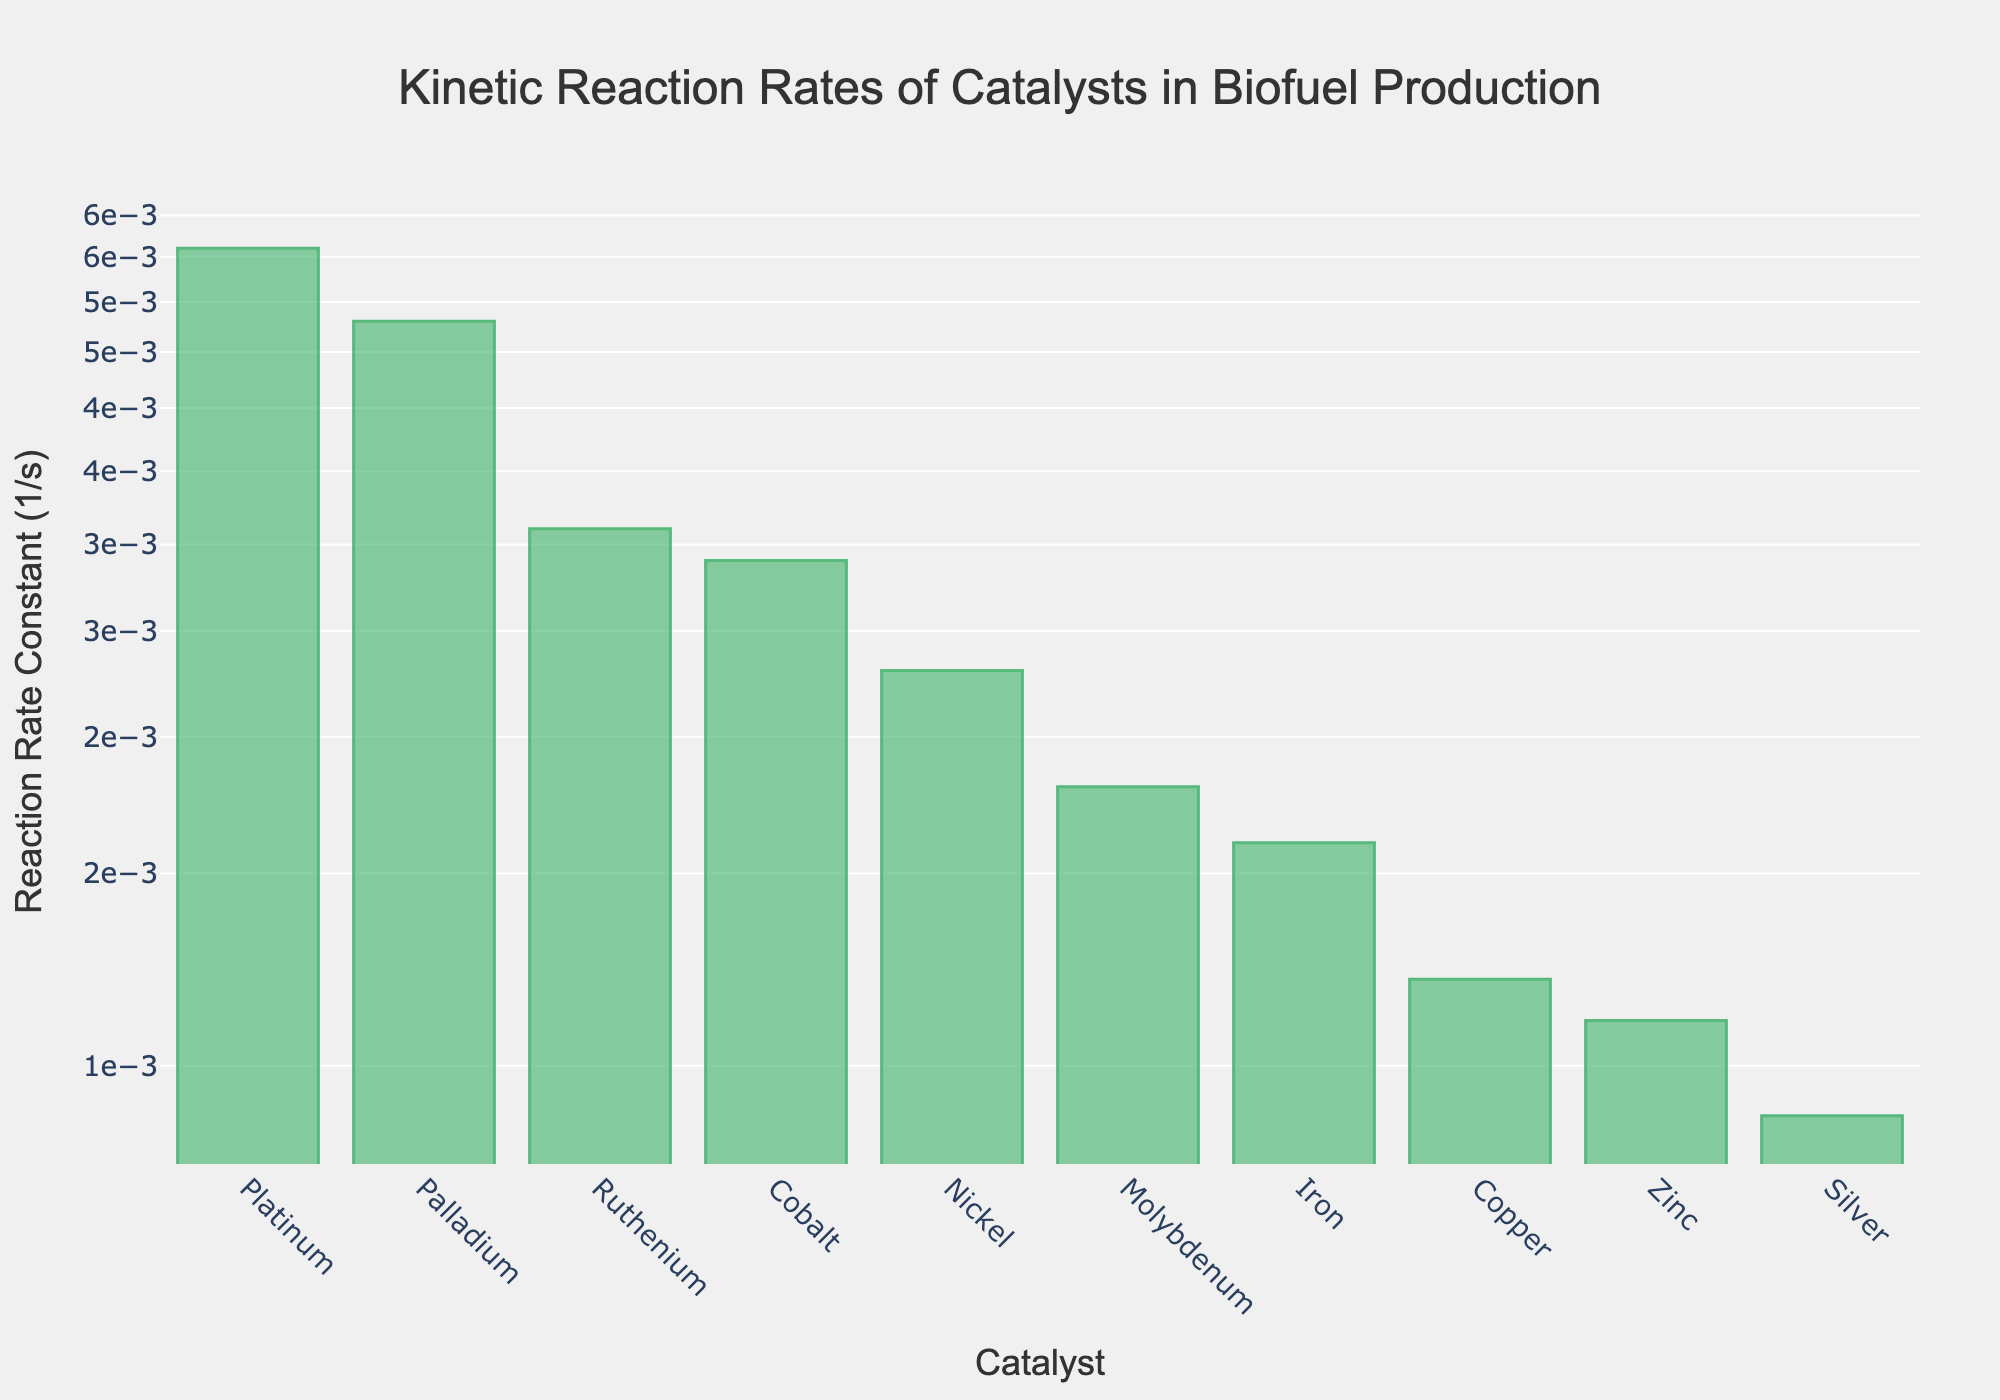What is the title of the plot? The title of the plot is centered at the top of the figure. By checking the figure, we see the title text clearly displayed.
Answer: Kinetic Reaction Rates of Catalysts in Biofuel Production Which catalyst has the highest reaction rate constant? By examining the bars on the log scale plot, the tallest bar represents the highest reaction rate constant. The label on this bar indicates the catalyst.
Answer: Platinum How many catalysts have a reaction rate constant higher than 0.002 1/s? By inspecting the bars in the plot, count the number of bars with y-values greater than 0.002.
Answer: 4 What are the reaction rate constants for Nickel and Cobalt? Find the bars labeled 'Nickel' and 'Cobalt' on the x-axis and read their corresponding y-values on the log scale.
Answer: 0.0023 1/s for Nickel, 0.0029 1/s for Cobalt What is the difference in reaction rate constant between Platinum and Zinc? Find the reaction rate constants for Platinum and Zinc from the plot, then subtract the Zinc constant from the Platinum constant.
Answer: 0.0056 1/s - 0.0011 1/s = 0.0045 1/s Which catalysts have reaction rate constants below 0.002 1/s? Identify all the bars that have y-values less than 0.002 on the y-axis and note their corresponding x-axis labels.
Answer: Copper, Iron, Molybdenum, Zinc, Silver What is the average reaction rate constant of the catalysts? Sum all the reaction rate constants and divide by the total number of catalysts (10).
Answer: (0.0023 + 0.0056 + 0.0031 + 0.0048 + 0.0012 + 0.0029 + 0.0016 + 0.0018 + 0.0011 + 0.0009) / 10 = 0.00253 1/s Which catalyst has the closest reaction rate constant to 0.002 1/s? Find the value closest to 0.002 on the y-axis, then identify the corresponding catalyst from the x-axis label.
Answer: Nickel 